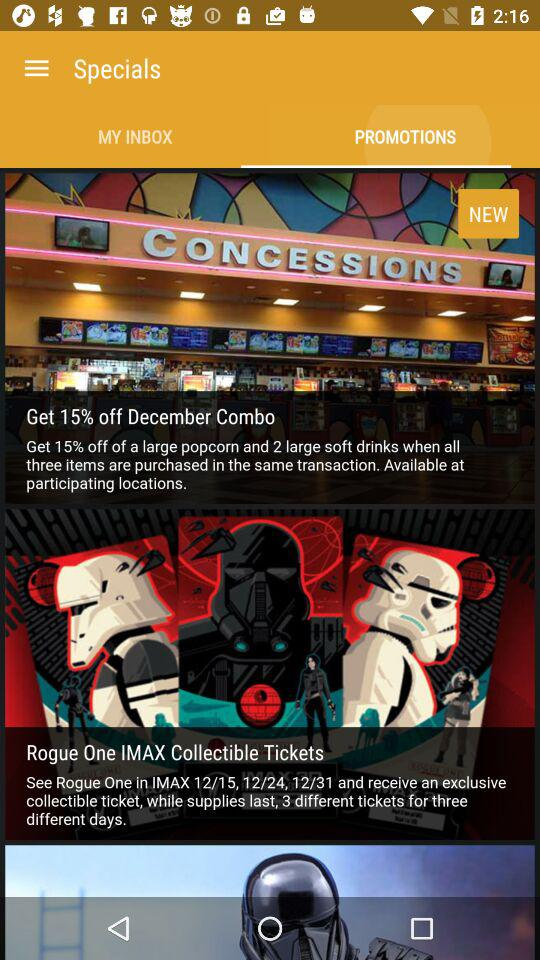When will we get the 15% discount? You will get the 15% discount when all three items are purchased in the same transaction. 